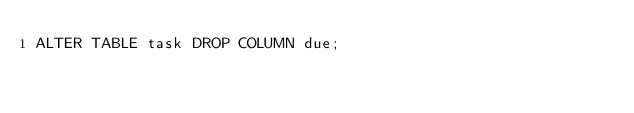<code> <loc_0><loc_0><loc_500><loc_500><_SQL_>ALTER TABLE task DROP COLUMN due;
</code> 